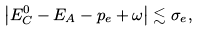<formula> <loc_0><loc_0><loc_500><loc_500>\left | E ^ { 0 } _ { C } - E _ { A } - p _ { e } + \omega \right | \lesssim \sigma _ { e } ,</formula> 